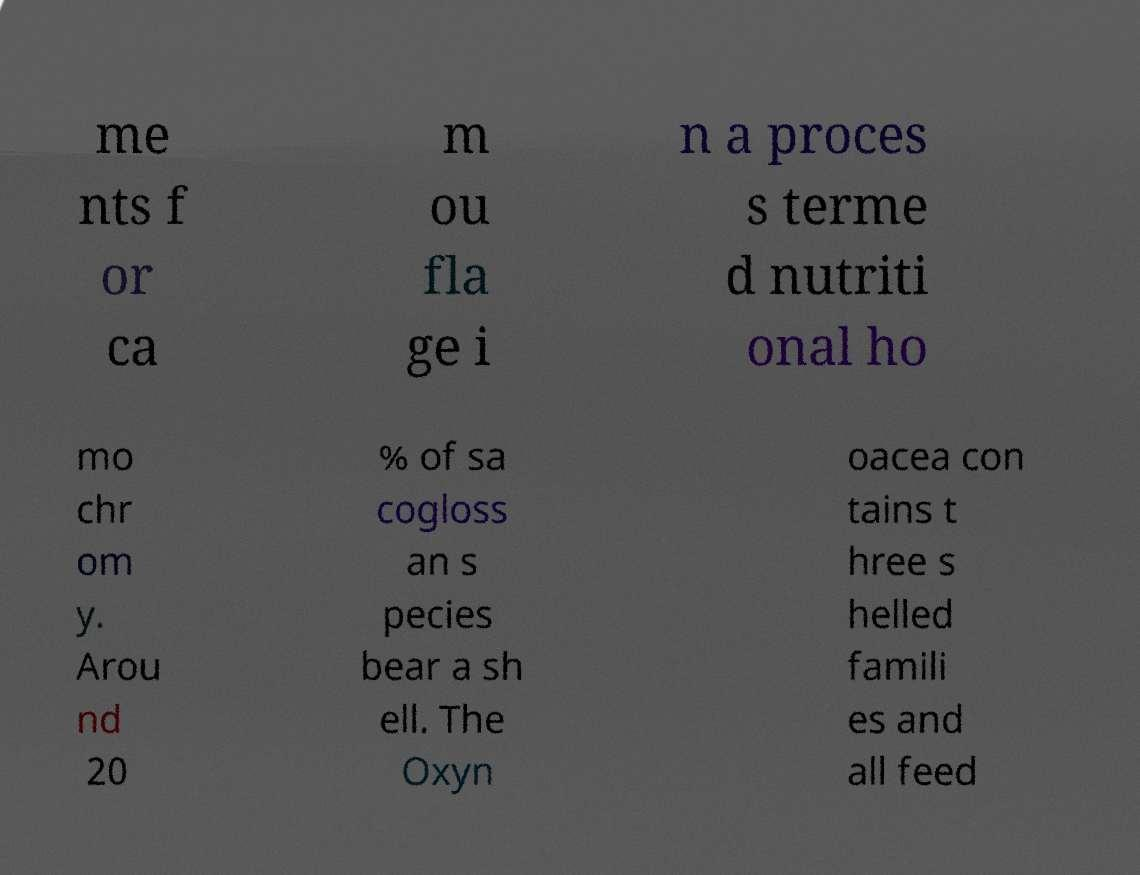Could you extract and type out the text from this image? me nts f or ca m ou fla ge i n a proces s terme d nutriti onal ho mo chr om y. Arou nd 20 % of sa cogloss an s pecies bear a sh ell. The Oxyn oacea con tains t hree s helled famili es and all feed 